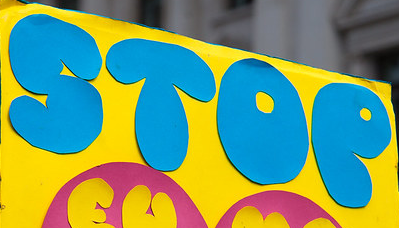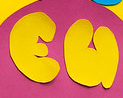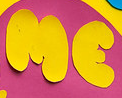What text appears in these images from left to right, separated by a semicolon? STOP; EU; ME 